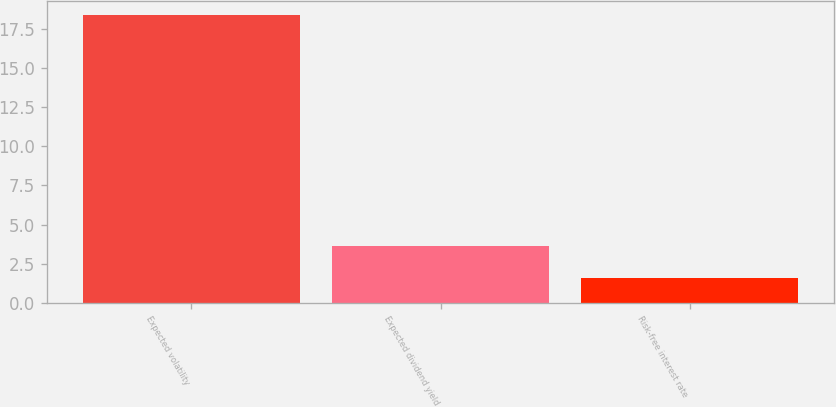<chart> <loc_0><loc_0><loc_500><loc_500><bar_chart><fcel>Expected volatility<fcel>Expected dividend yield<fcel>Risk-free interest rate<nl><fcel>18.4<fcel>3.6<fcel>1.6<nl></chart> 